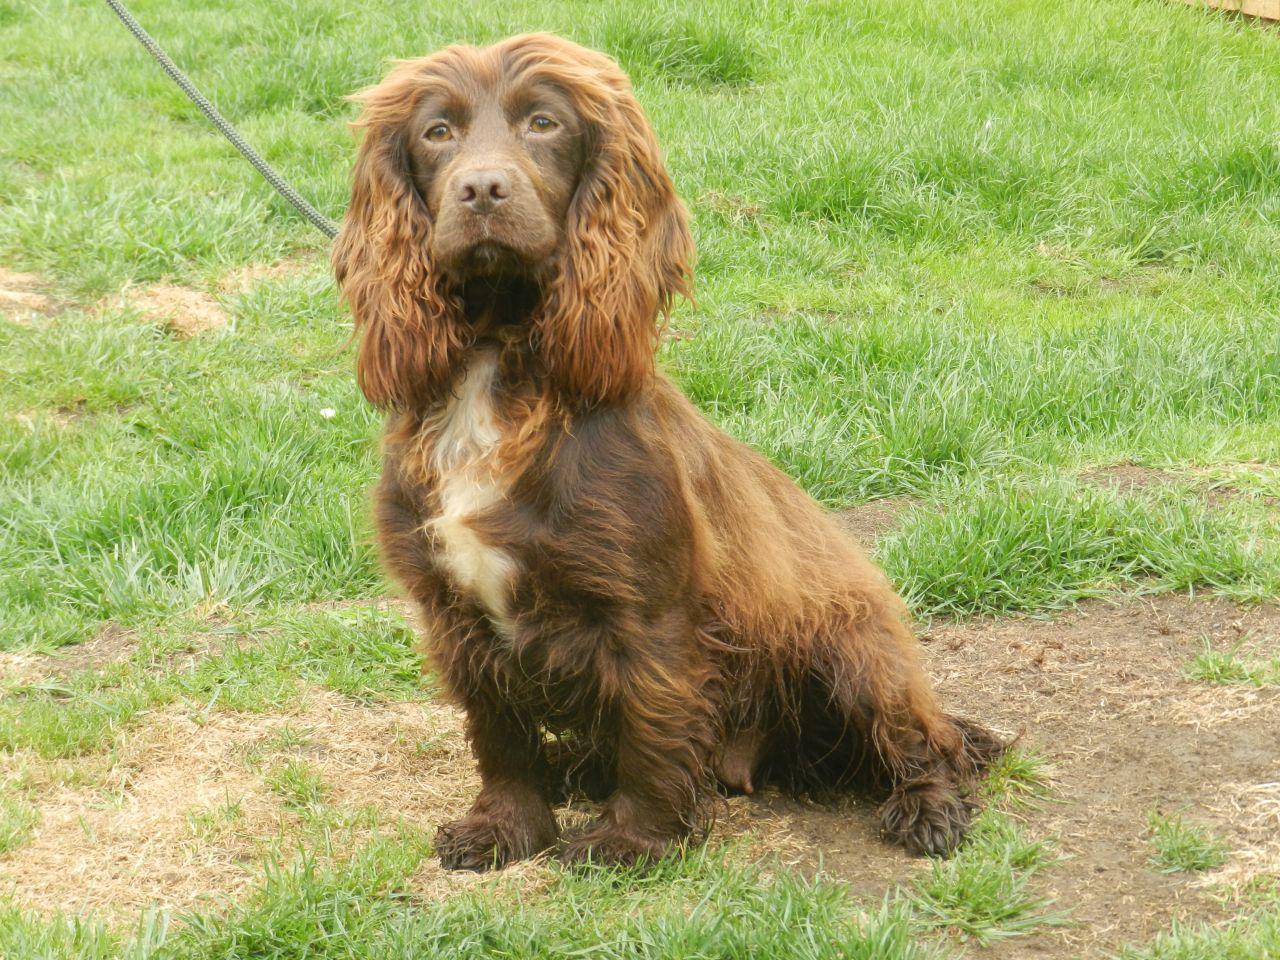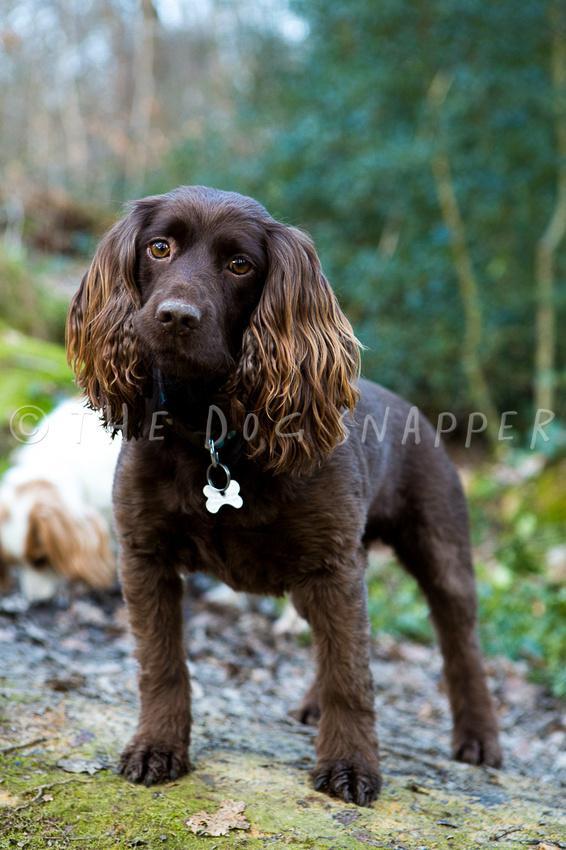The first image is the image on the left, the second image is the image on the right. For the images shown, is this caption "At least one dog is wearing a dog tag on its collar." true? Answer yes or no. Yes. The first image is the image on the left, the second image is the image on the right. Examine the images to the left and right. Is the description "The dog on the right has a charm dangling from its collar, and the dog on the left is sitting upright outdoors with something around its neck." accurate? Answer yes or no. Yes. 